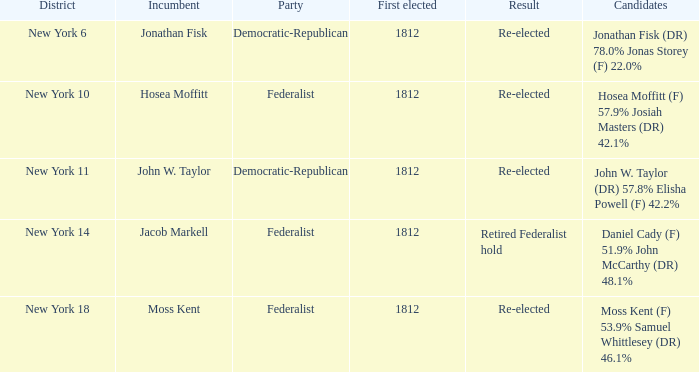Name the first elected for jacob markell 1812.0. Give me the full table as a dictionary. {'header': ['District', 'Incumbent', 'Party', 'First elected', 'Result', 'Candidates'], 'rows': [['New York 6', 'Jonathan Fisk', 'Democratic-Republican', '1812', 'Re-elected', 'Jonathan Fisk (DR) 78.0% Jonas Storey (F) 22.0%'], ['New York 10', 'Hosea Moffitt', 'Federalist', '1812', 'Re-elected', 'Hosea Moffitt (F) 57.9% Josiah Masters (DR) 42.1%'], ['New York 11', 'John W. Taylor', 'Democratic-Republican', '1812', 'Re-elected', 'John W. Taylor (DR) 57.8% Elisha Powell (F) 42.2%'], ['New York 14', 'Jacob Markell', 'Federalist', '1812', 'Retired Federalist hold', 'Daniel Cady (F) 51.9% John McCarthy (DR) 48.1%'], ['New York 18', 'Moss Kent', 'Federalist', '1812', 'Re-elected', 'Moss Kent (F) 53.9% Samuel Whittlesey (DR) 46.1%']]} 